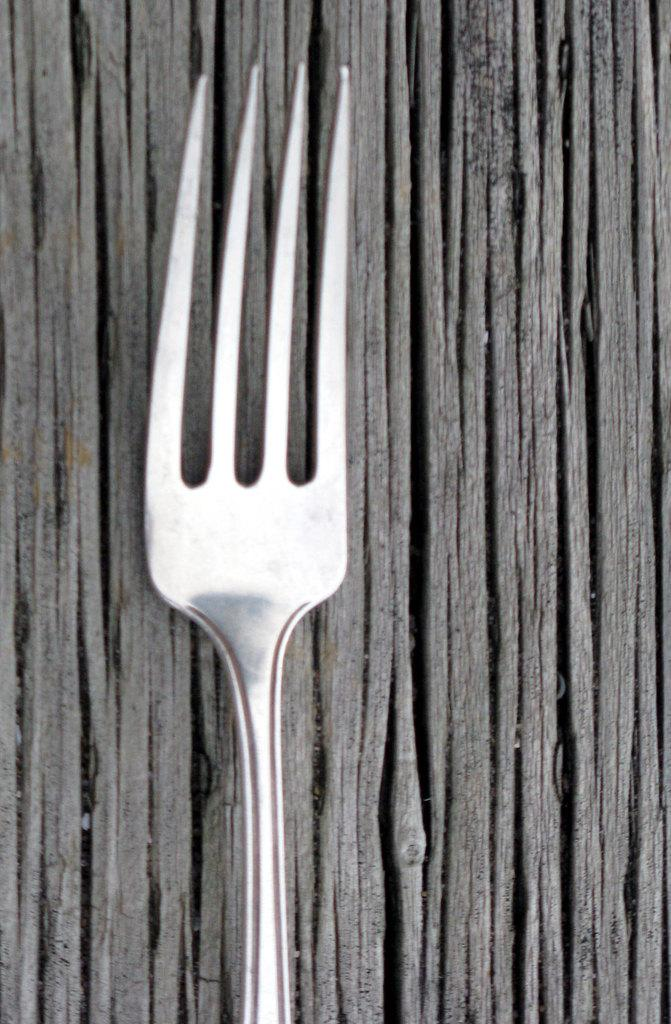What utensil can be seen in the image? There is a fork in the image. Where is the fork located? The fork is placed on a table. What type of sock is being used to express hate in the library in the image? There is no sock, hate, or library present in the image; it only features a fork placed on a table. 